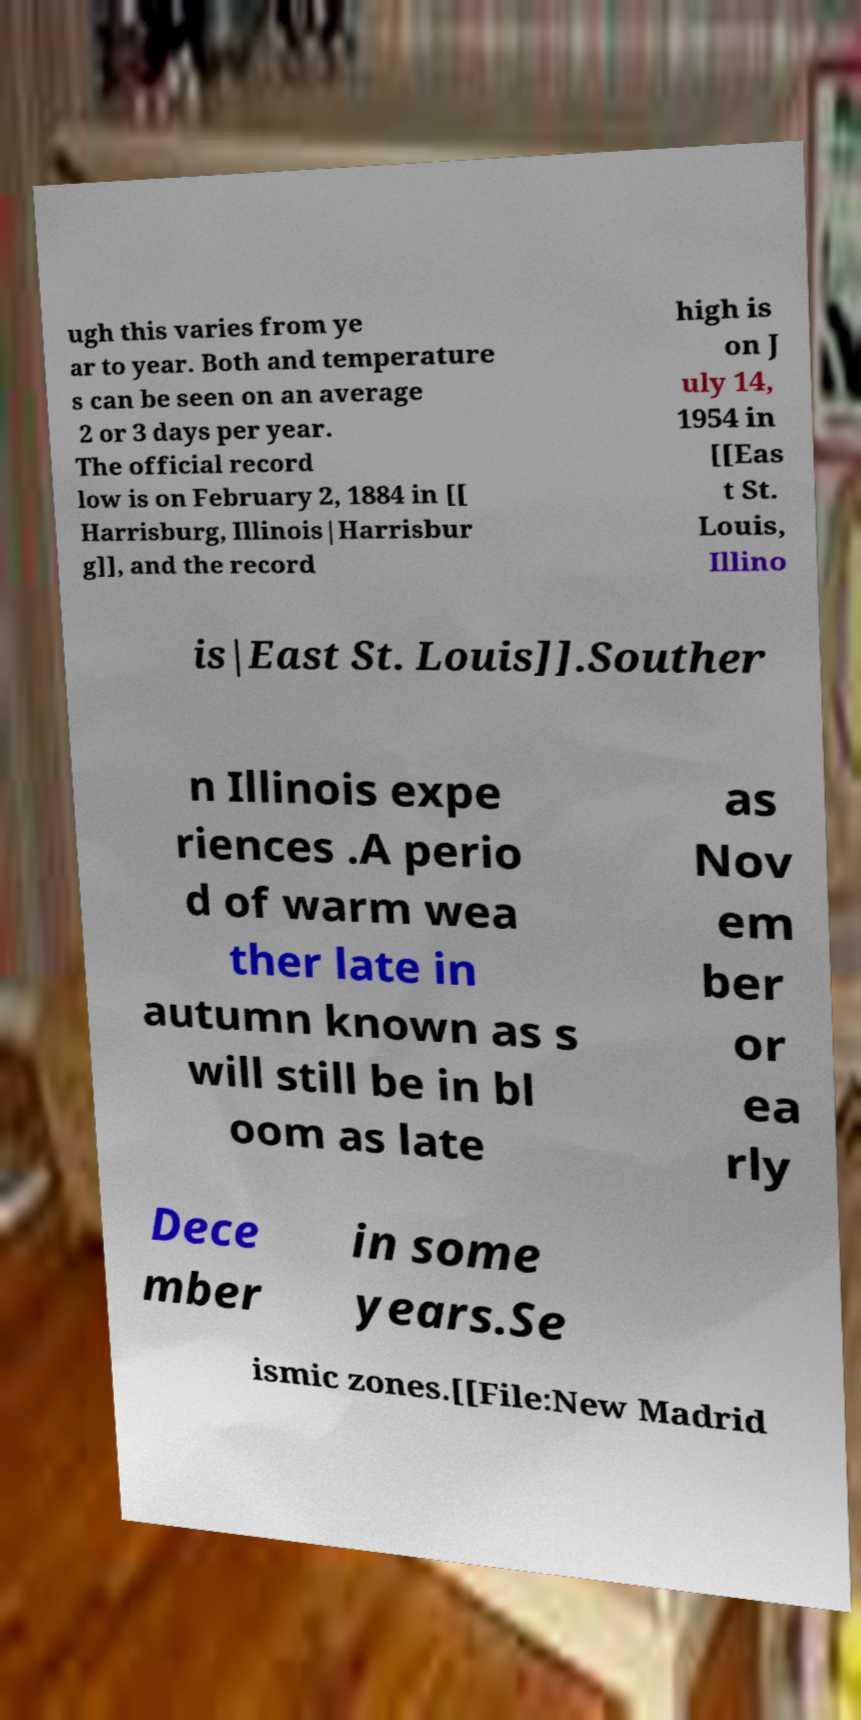Can you accurately transcribe the text from the provided image for me? ugh this varies from ye ar to year. Both and temperature s can be seen on an average 2 or 3 days per year. The official record low is on February 2, 1884 in [[ Harrisburg, Illinois|Harrisbur g]], and the record high is on J uly 14, 1954 in [[Eas t St. Louis, Illino is|East St. Louis]].Souther n Illinois expe riences .A perio d of warm wea ther late in autumn known as s will still be in bl oom as late as Nov em ber or ea rly Dece mber in some years.Se ismic zones.[[File:New Madrid 